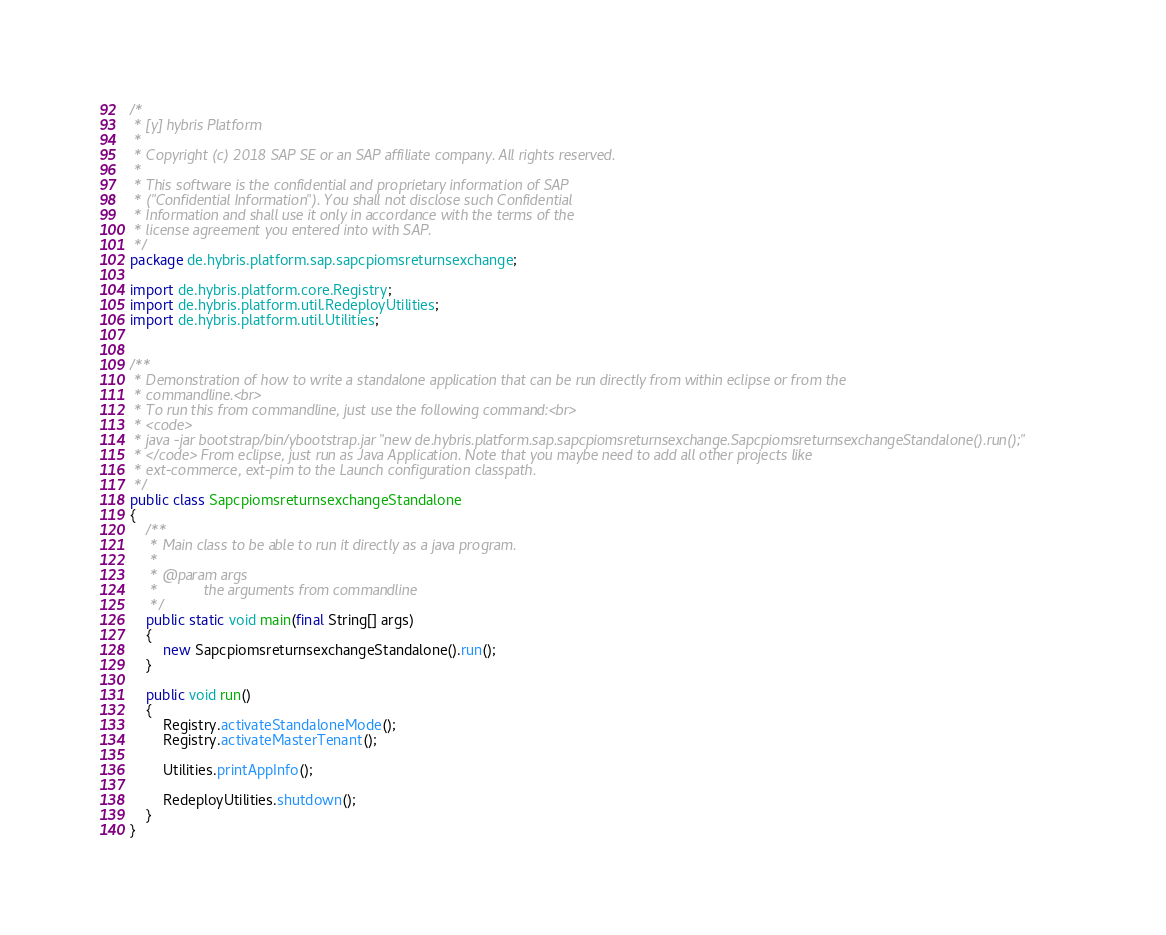<code> <loc_0><loc_0><loc_500><loc_500><_Java_>/*
 * [y] hybris Platform
 *
 * Copyright (c) 2018 SAP SE or an SAP affiliate company. All rights reserved.
 *
 * This software is the confidential and proprietary information of SAP
 * ("Confidential Information"). You shall not disclose such Confidential
 * Information and shall use it only in accordance with the terms of the
 * license agreement you entered into with SAP.
 */
package de.hybris.platform.sap.sapcpiomsreturnsexchange;

import de.hybris.platform.core.Registry;
import de.hybris.platform.util.RedeployUtilities;
import de.hybris.platform.util.Utilities;


/**
 * Demonstration of how to write a standalone application that can be run directly from within eclipse or from the
 * commandline.<br>
 * To run this from commandline, just use the following command:<br>
 * <code>
 * java -jar bootstrap/bin/ybootstrap.jar "new de.hybris.platform.sap.sapcpiomsreturnsexchange.SapcpiomsreturnsexchangeStandalone().run();"
 * </code> From eclipse, just run as Java Application. Note that you maybe need to add all other projects like
 * ext-commerce, ext-pim to the Launch configuration classpath.
 */
public class SapcpiomsreturnsexchangeStandalone
{
	/**
	 * Main class to be able to run it directly as a java program.
	 *
	 * @param args
	 *           the arguments from commandline
	 */
	public static void main(final String[] args)
	{
		new SapcpiomsreturnsexchangeStandalone().run();
	}

	public void run()
	{
		Registry.activateStandaloneMode();
		Registry.activateMasterTenant();

		Utilities.printAppInfo();

		RedeployUtilities.shutdown();
	}
}
</code> 